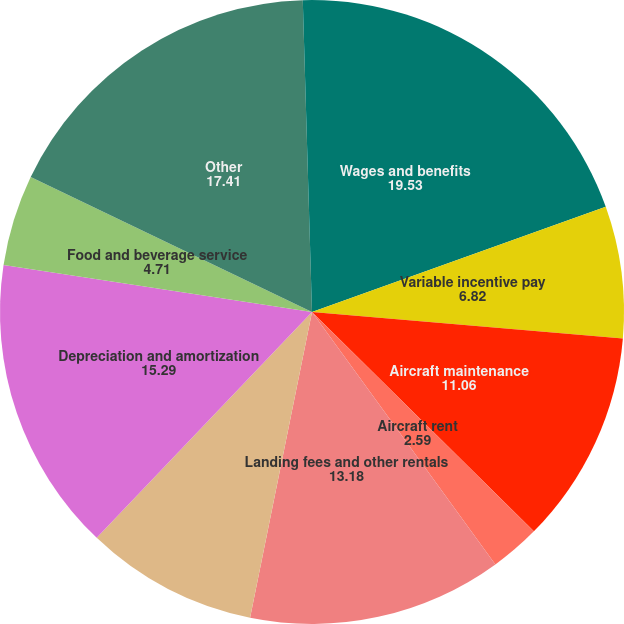<chart> <loc_0><loc_0><loc_500><loc_500><pie_chart><fcel>Wages and benefits<fcel>Variable incentive pay<fcel>Aircraft maintenance<fcel>Aircraft rent<fcel>Landing fees and other rentals<fcel>Selling expenses<fcel>Depreciation and amortization<fcel>Food and beverage service<fcel>Other<fcel>Third-party regional carrier<nl><fcel>19.53%<fcel>6.82%<fcel>11.06%<fcel>2.59%<fcel>13.18%<fcel>8.94%<fcel>15.29%<fcel>4.71%<fcel>17.41%<fcel>0.47%<nl></chart> 